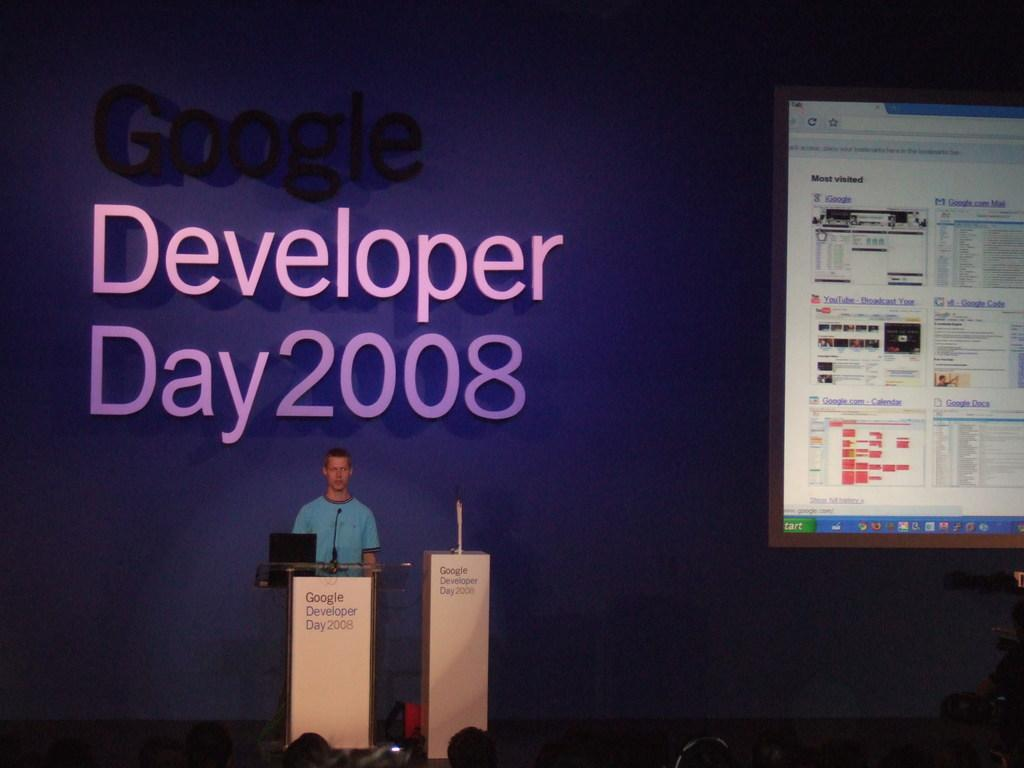<image>
Summarize the visual content of the image. Speaker standing behind podium on Google Developer Day. 